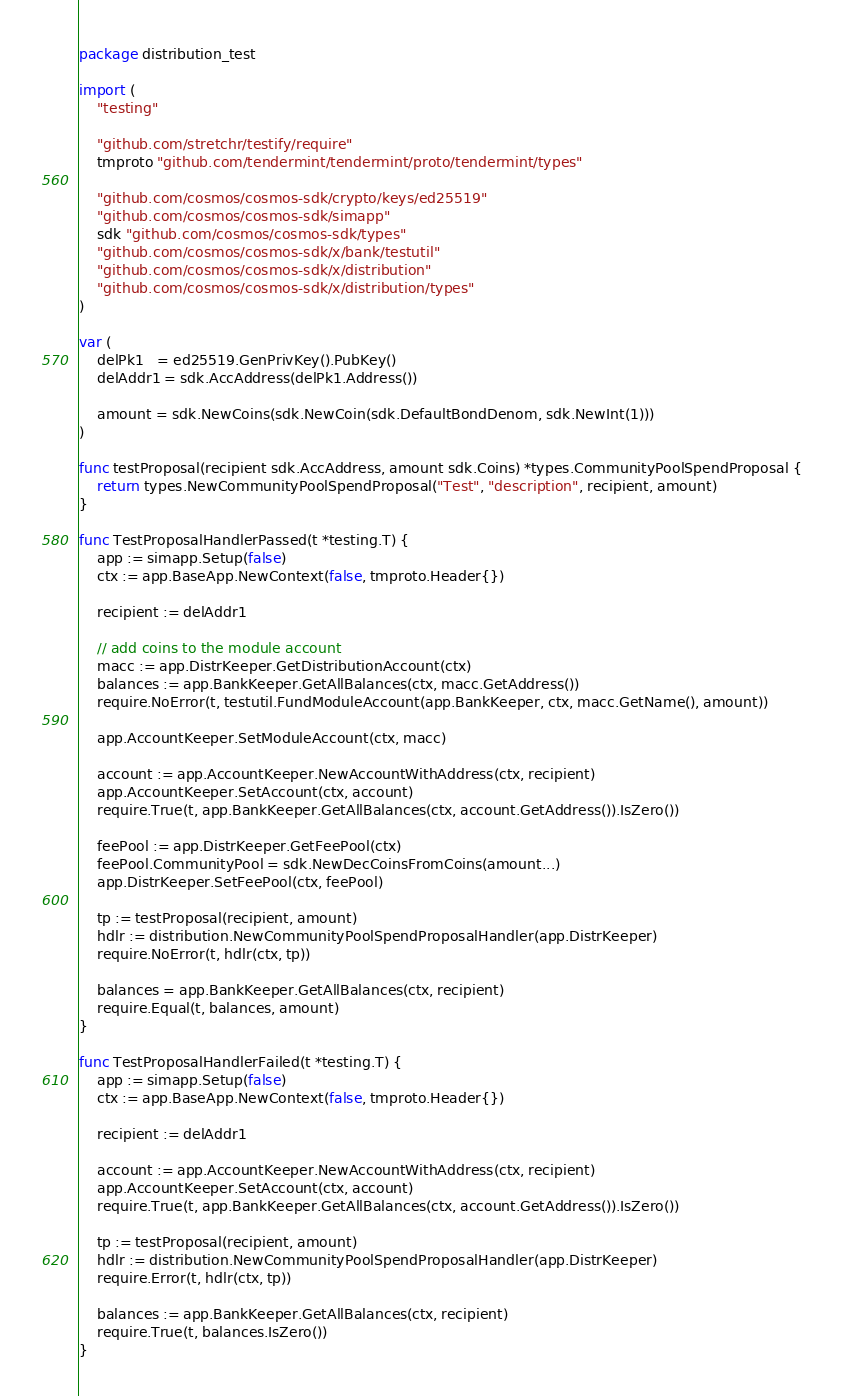<code> <loc_0><loc_0><loc_500><loc_500><_Go_>package distribution_test

import (
	"testing"

	"github.com/stretchr/testify/require"
	tmproto "github.com/tendermint/tendermint/proto/tendermint/types"

	"github.com/cosmos/cosmos-sdk/crypto/keys/ed25519"
	"github.com/cosmos/cosmos-sdk/simapp"
	sdk "github.com/cosmos/cosmos-sdk/types"
	"github.com/cosmos/cosmos-sdk/x/bank/testutil"
	"github.com/cosmos/cosmos-sdk/x/distribution"
	"github.com/cosmos/cosmos-sdk/x/distribution/types"
)

var (
	delPk1   = ed25519.GenPrivKey().PubKey()
	delAddr1 = sdk.AccAddress(delPk1.Address())

	amount = sdk.NewCoins(sdk.NewCoin(sdk.DefaultBondDenom, sdk.NewInt(1)))
)

func testProposal(recipient sdk.AccAddress, amount sdk.Coins) *types.CommunityPoolSpendProposal {
	return types.NewCommunityPoolSpendProposal("Test", "description", recipient, amount)
}

func TestProposalHandlerPassed(t *testing.T) {
	app := simapp.Setup(false)
	ctx := app.BaseApp.NewContext(false, tmproto.Header{})

	recipient := delAddr1

	// add coins to the module account
	macc := app.DistrKeeper.GetDistributionAccount(ctx)
	balances := app.BankKeeper.GetAllBalances(ctx, macc.GetAddress())
	require.NoError(t, testutil.FundModuleAccount(app.BankKeeper, ctx, macc.GetName(), amount))

	app.AccountKeeper.SetModuleAccount(ctx, macc)

	account := app.AccountKeeper.NewAccountWithAddress(ctx, recipient)
	app.AccountKeeper.SetAccount(ctx, account)
	require.True(t, app.BankKeeper.GetAllBalances(ctx, account.GetAddress()).IsZero())

	feePool := app.DistrKeeper.GetFeePool(ctx)
	feePool.CommunityPool = sdk.NewDecCoinsFromCoins(amount...)
	app.DistrKeeper.SetFeePool(ctx, feePool)

	tp := testProposal(recipient, amount)
	hdlr := distribution.NewCommunityPoolSpendProposalHandler(app.DistrKeeper)
	require.NoError(t, hdlr(ctx, tp))

	balances = app.BankKeeper.GetAllBalances(ctx, recipient)
	require.Equal(t, balances, amount)
}

func TestProposalHandlerFailed(t *testing.T) {
	app := simapp.Setup(false)
	ctx := app.BaseApp.NewContext(false, tmproto.Header{})

	recipient := delAddr1

	account := app.AccountKeeper.NewAccountWithAddress(ctx, recipient)
	app.AccountKeeper.SetAccount(ctx, account)
	require.True(t, app.BankKeeper.GetAllBalances(ctx, account.GetAddress()).IsZero())

	tp := testProposal(recipient, amount)
	hdlr := distribution.NewCommunityPoolSpendProposalHandler(app.DistrKeeper)
	require.Error(t, hdlr(ctx, tp))

	balances := app.BankKeeper.GetAllBalances(ctx, recipient)
	require.True(t, balances.IsZero())
}
</code> 